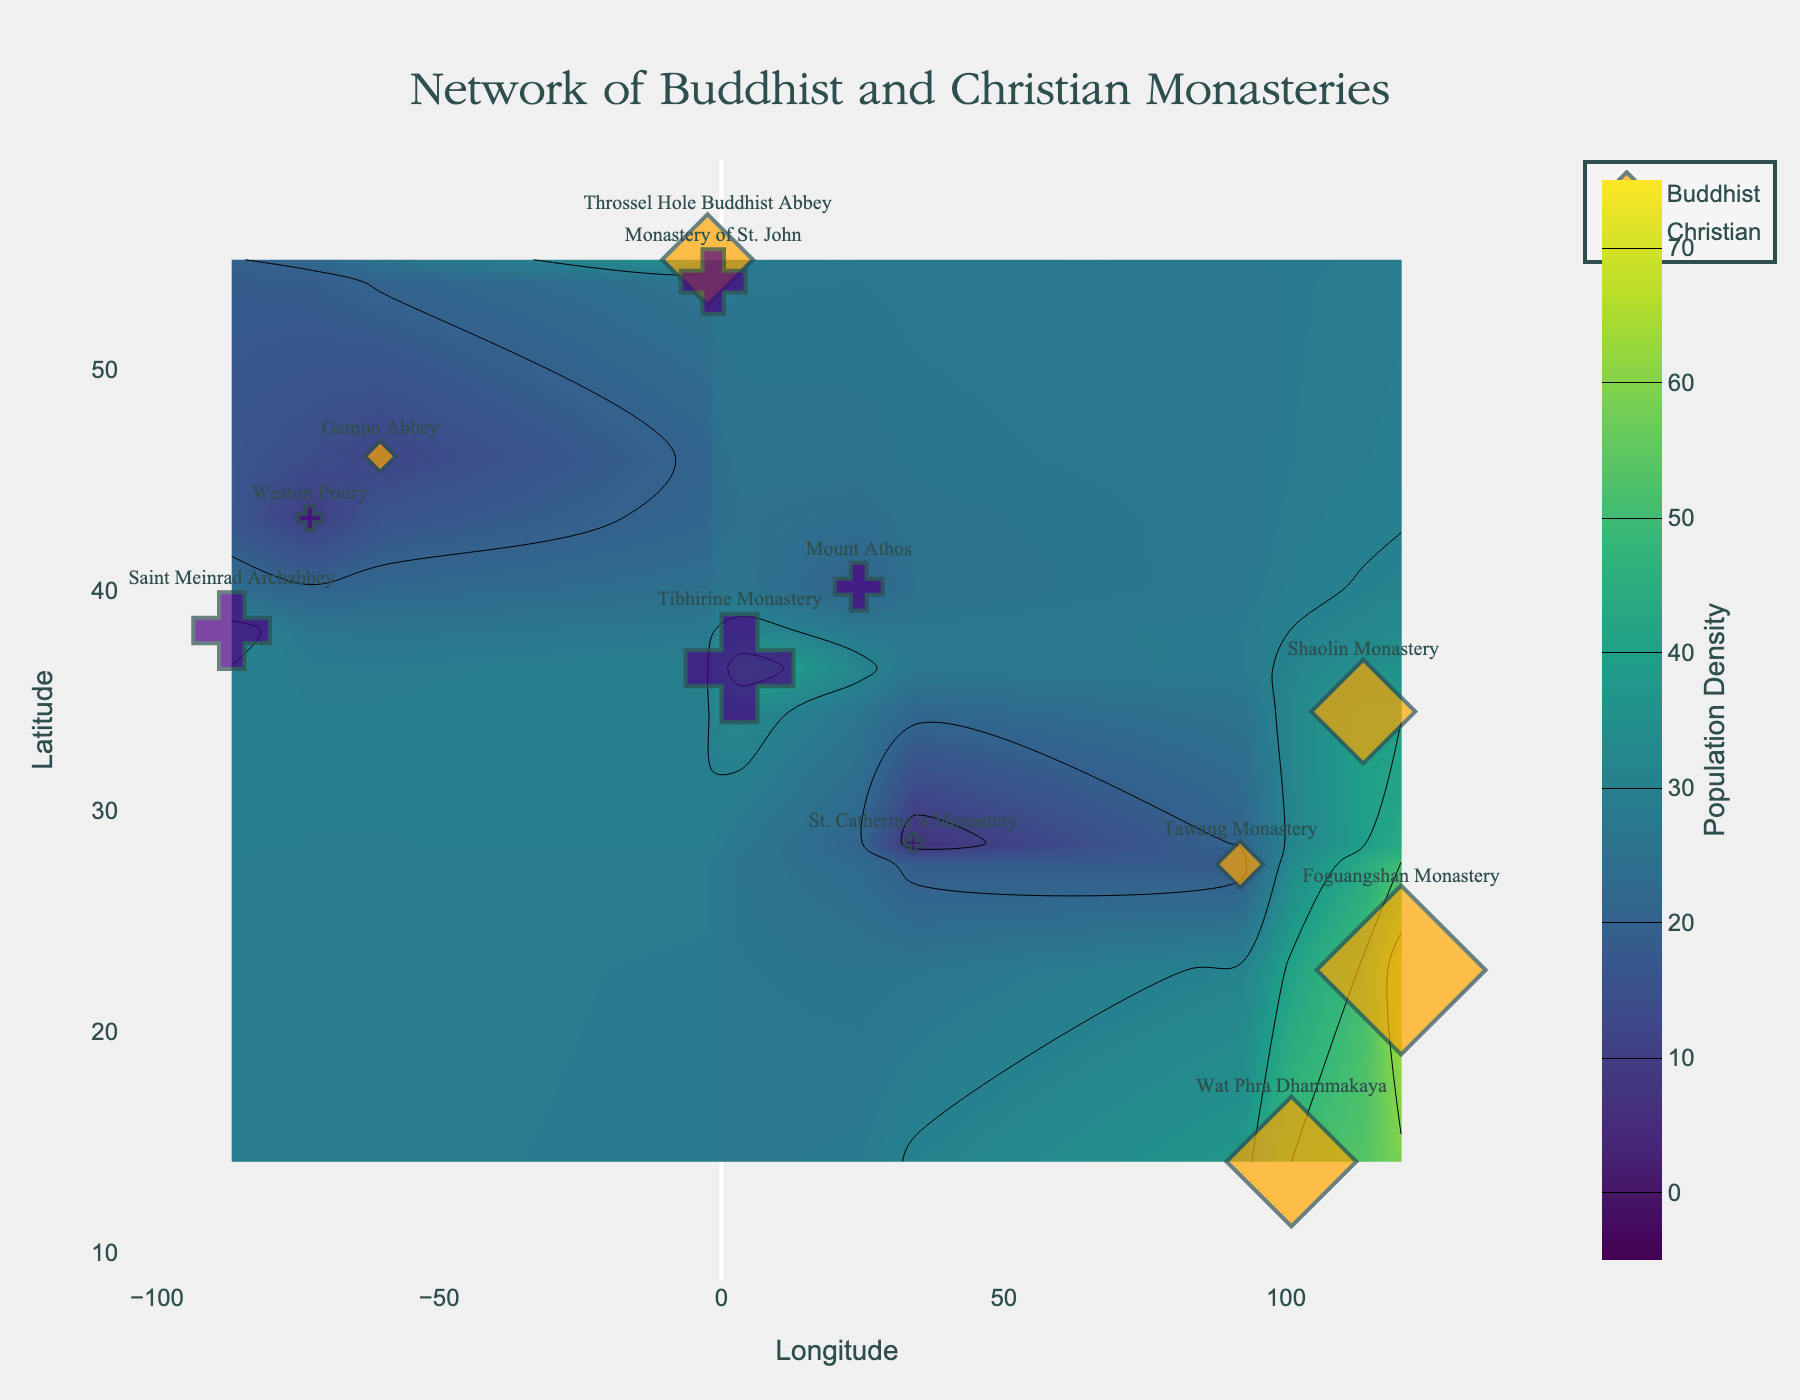How many Buddhist monasteries are represented in the figure? Count the number of data points labeled as Buddhist.
Answer: 5 Which location has the highest population density? Identify the location associated with the largest marker size (circle/diamond).
Answer: Foguangshan Monastery What's the average population density of Christian locations? Sum the population density values of all Christian locations and divide by the number of Christian locations. (45 + 20 + 27 + 7 + 32 + 10) / 6
Answer: 23.5 Compare the population density between Throssel Hole Buddhist Abbey and Monastery of St. John, which one is higher? Find the population density values for each location and compare them.
Answer: Throssel Hole Buddhist Abbey (35) is higher than Monastery of St. John (27) Are there more Buddhist locations or Christian locations in the figure? Count the number of data points for each type (Buddhist and Christian) and compare.
Answer: Christian (6 locations) are more than Buddhist (5 locations) What latitude and longitude values represent Mount Athos? Locate the data point labeled "Mount Athos" and list its latitude and longitude values.
Answer: Latitude: 40.1582, Longitude: 24.3260 Identify a Buddhist monastery with a low population density on the figure. Look for a Buddhist location with a small marker size (circle/diamond) indicating low population density.
Answer: Gampo Abbey Is the population density at Wat Phra Dhammakaya above or below 50? Check the population density value associated with Wat Phra Dhammakaya.
Answer: Above (50) Compare the population densities of Tawang Monastery and St. Catherine’s Monastery, which one has a lower population density? Find the population density values for each location and compare them.
Answer: St. Catherine’s Monastery (7) has a lower population density than Tawang Monastery (18) What can you infer about the geographic distribution of Christian locations in comparison to Buddhist locations based on latitude? Observe the latitude values of Christian and Buddhist locations to infer their geographic spread.
Answer: Christian locations are more spread across diverse latitudes, whereas Buddhist ones are primarily concentrated in Asia 